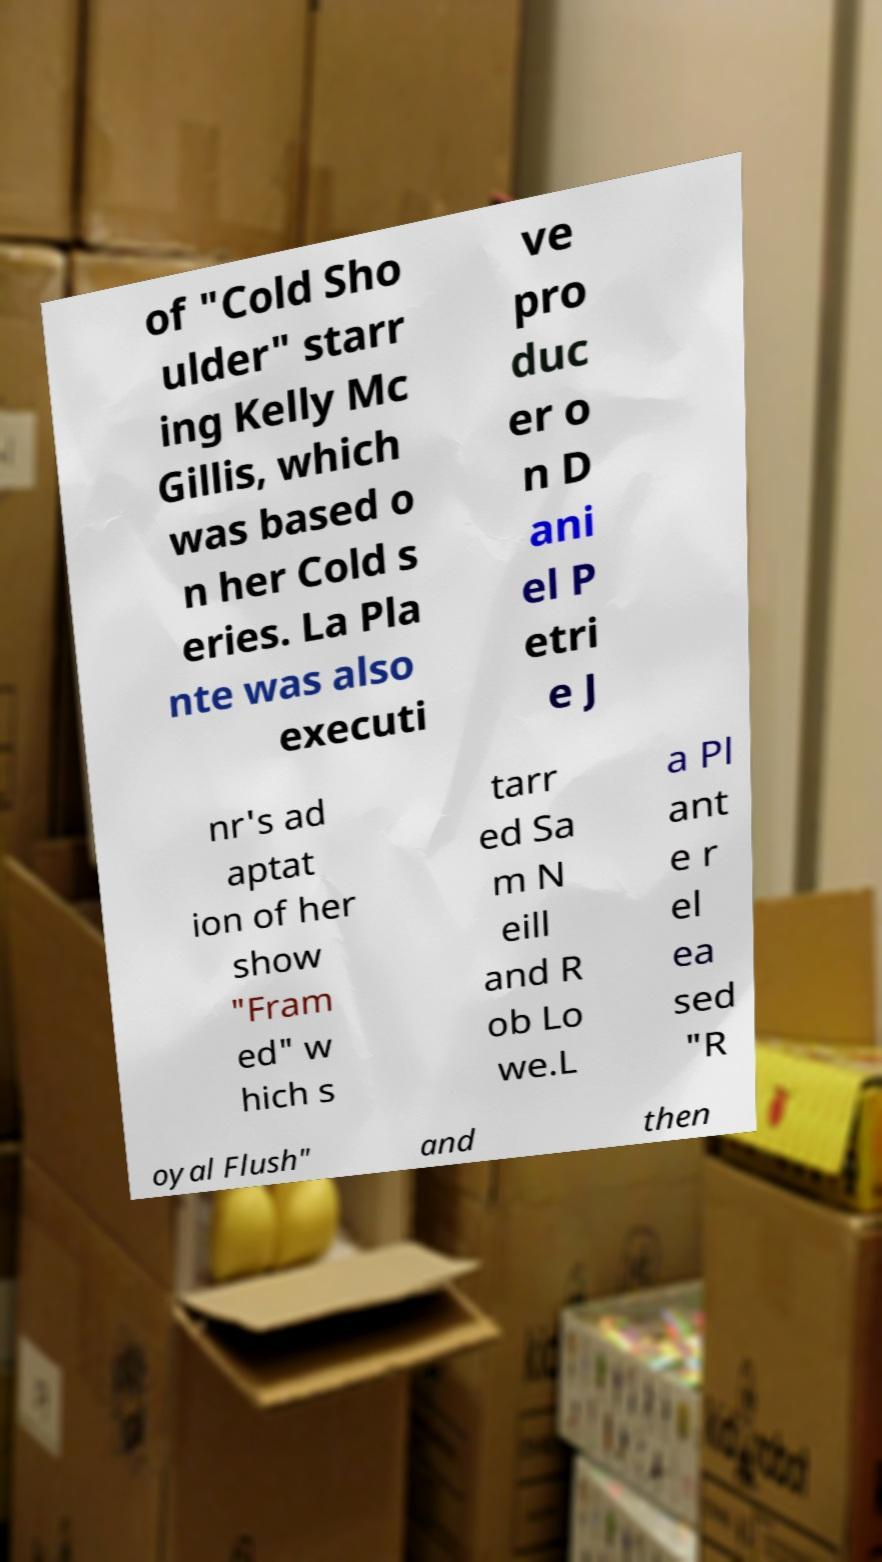Please read and relay the text visible in this image. What does it say? of "Cold Sho ulder" starr ing Kelly Mc Gillis, which was based o n her Cold s eries. La Pla nte was also executi ve pro duc er o n D ani el P etri e J nr's ad aptat ion of her show "Fram ed" w hich s tarr ed Sa m N eill and R ob Lo we.L a Pl ant e r el ea sed "R oyal Flush" and then 